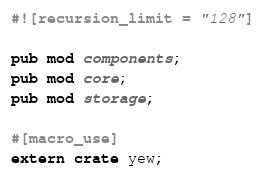Convert code to text. <code><loc_0><loc_0><loc_500><loc_500><_Rust_>#![recursion_limit = "128"]

pub mod components;
pub mod core;
pub mod storage;

#[macro_use]
extern crate yew;
</code> 